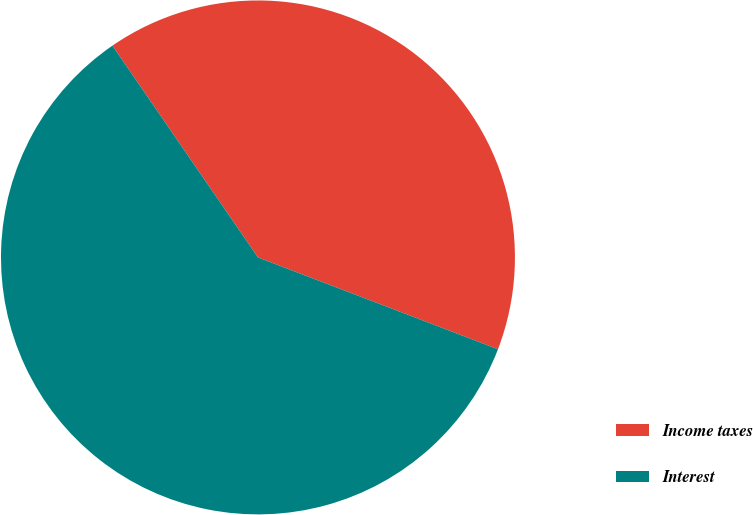Convert chart. <chart><loc_0><loc_0><loc_500><loc_500><pie_chart><fcel>Income taxes<fcel>Interest<nl><fcel>40.4%<fcel>59.6%<nl></chart> 